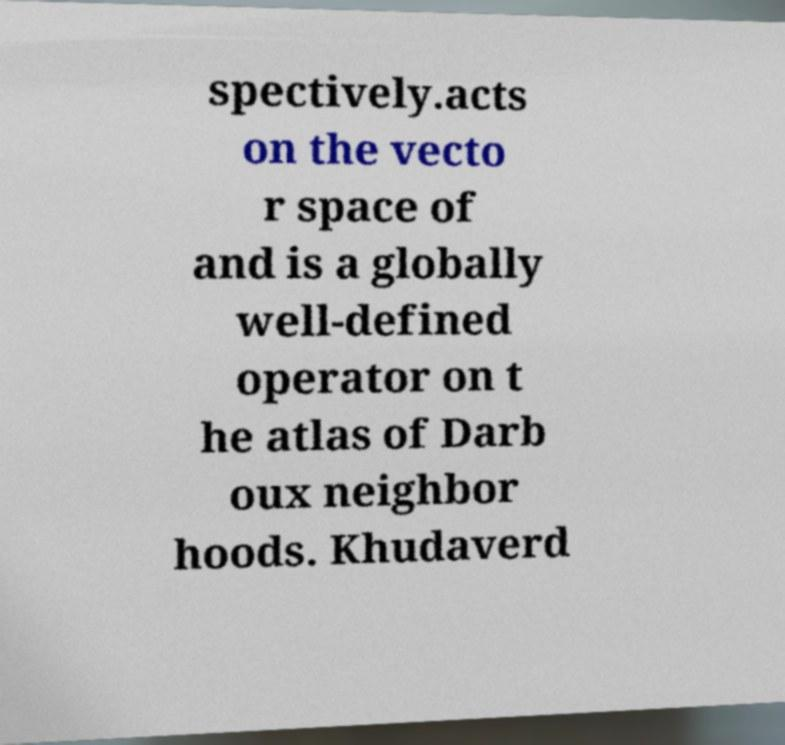There's text embedded in this image that I need extracted. Can you transcribe it verbatim? spectively.acts on the vecto r space of and is a globally well-defined operator on t he atlas of Darb oux neighbor hoods. Khudaverd 